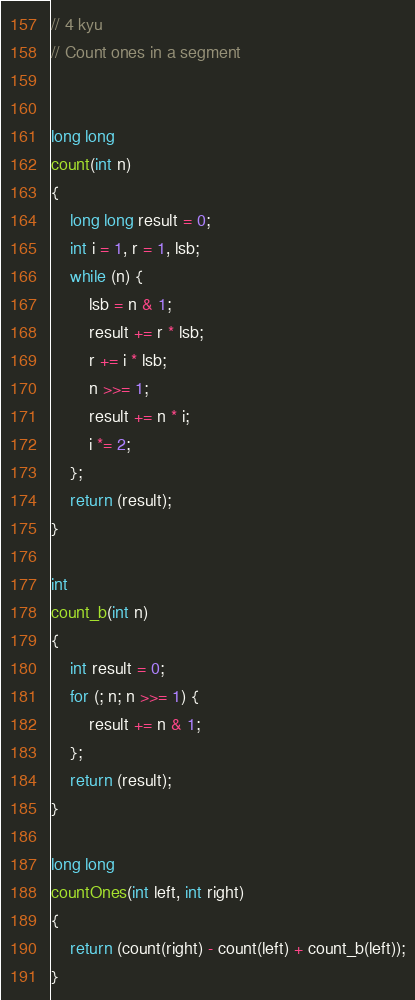<code> <loc_0><loc_0><loc_500><loc_500><_C_>// 4 kyu
// Count ones in a segment


long long
count(int n)
{
	long long result = 0;
	int i = 1, r = 1, lsb;
	while (n) {
		lsb = n & 1;
		result += r * lsb;
		r += i * lsb;
		n >>= 1;
		result += n * i;
		i *= 2;
	};
	return (result);
}

int
count_b(int n)
{
	int result = 0;
	for (; n; n >>= 1) {
		result += n & 1;
	};
	return (result);
}

long long
countOnes(int left, int right)
{
	return (count(right) - count(left) + count_b(left));
}
</code> 